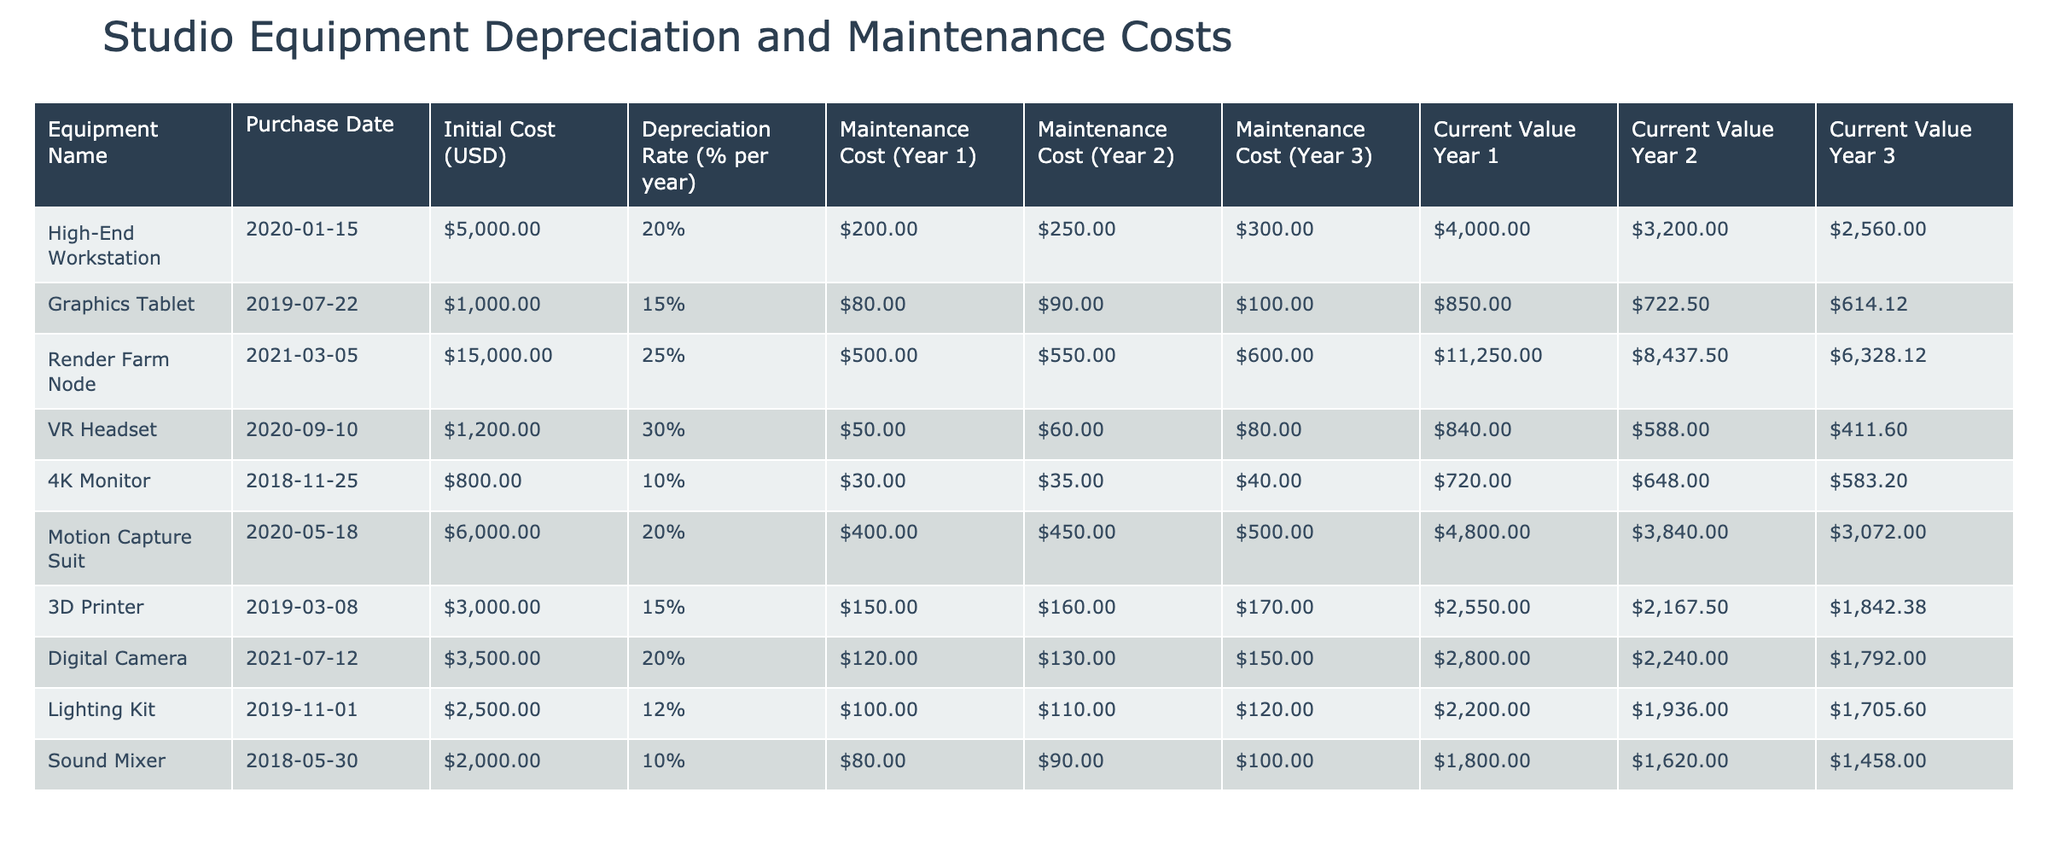What is the current value of the Graphics Tablet in Year 3? The current value of the Graphics Tablet in Year 3 is listed under the "Current Value Year 3" column. Referring to the table, the value for the Graphics Tablet is $614.125.
Answer: $614.125 What is the total maintenance cost for the Render Farm Node across all three years? To find the total maintenance cost for the Render Farm Node, sum the values from the "Maintenance Cost (Year 1)", "Maintenance Cost (Year 2)", and "Maintenance Cost (Year 3)" columns. This gives us 500 + 550 + 600 = 1650.
Answer: $1650 Which equipment has the highest depreciation rate, and what is that rate? To determine the equipment with the highest depreciation rate, we look at the "Depreciation Rate (% per year)" column and identify the maximum value. The Render Farm Node has the highest rate at 25%.
Answer: Render Farm Node, 25% Is the current value of the High-End Workstation in Year 2 more than $3,000? We find the current value of the High-End Workstation in Year 2 from the table, which is $3200. Since $3200 is greater than $3000, the answer is yes.
Answer: Yes What is the average current value of equipment in Year 1? To find the average current value for Year 1, sum the "Current Value Year 1" for all equipment and divide by the number of equipment types. The sum is 4000 + 850 + 11250 + 840 + 720 + 4800 + 2550 + 2800 + 2200 + 1800 = 23010. There are 10 pieces of equipment, so the average is 23010 / 10 = 2301.
Answer: $2301 